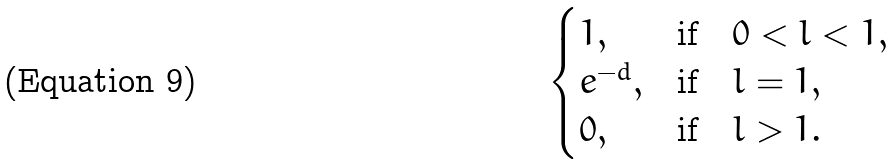Convert formula to latex. <formula><loc_0><loc_0><loc_500><loc_500>\begin{cases} 1 , & \text {if} \quad 0 < l < 1 , \\ e ^ { - d } , & \text {if} \quad l = 1 , \\ 0 , & \text {if} \quad l > 1 . \end{cases}</formula> 